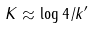Convert formula to latex. <formula><loc_0><loc_0><loc_500><loc_500>K \approx \log { 4 / k ^ { \prime } }</formula> 